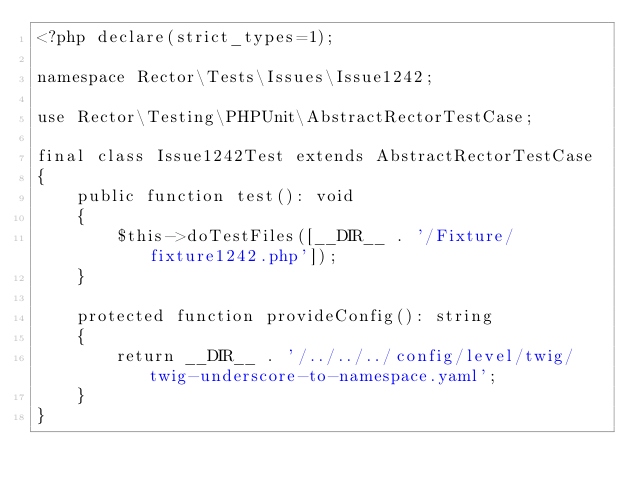<code> <loc_0><loc_0><loc_500><loc_500><_PHP_><?php declare(strict_types=1);

namespace Rector\Tests\Issues\Issue1242;

use Rector\Testing\PHPUnit\AbstractRectorTestCase;

final class Issue1242Test extends AbstractRectorTestCase
{
    public function test(): void
    {
        $this->doTestFiles([__DIR__ . '/Fixture/fixture1242.php']);
    }

    protected function provideConfig(): string
    {
        return __DIR__ . '/../../../config/level/twig/twig-underscore-to-namespace.yaml';
    }
}
</code> 